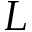Convert formula to latex. <formula><loc_0><loc_0><loc_500><loc_500>L</formula> 